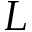Convert formula to latex. <formula><loc_0><loc_0><loc_500><loc_500>L</formula> 